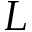Convert formula to latex. <formula><loc_0><loc_0><loc_500><loc_500>L</formula> 